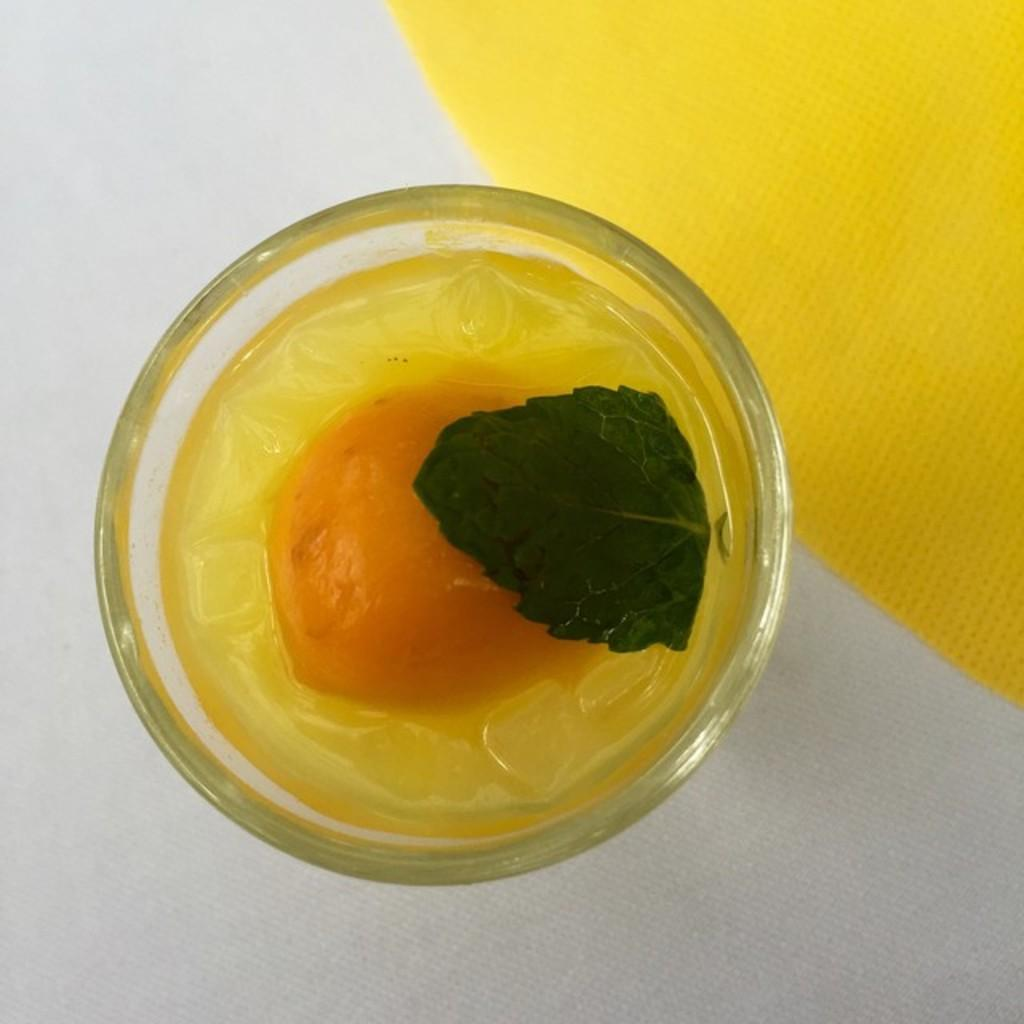What is located in the center of the image? There is a bowl in the center of the image. What is inside the bowl? The bowl contains liquid. Are there any additional objects in the bowl? Yes, there is a leaf in the bowl. Where can a tissue be found in the image? There is a tissue in the top right side of the image. What type of mine can be seen in the image? There is no mine present in the image. 